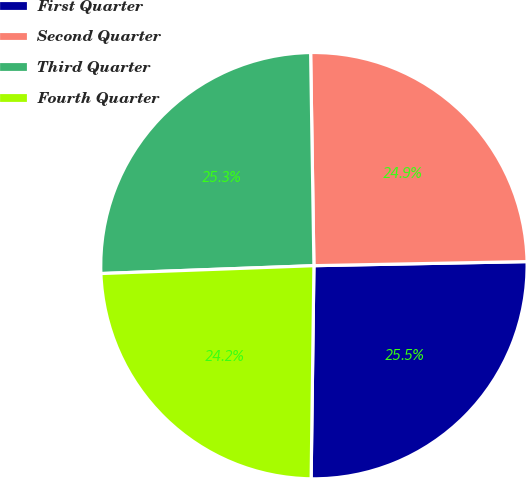<chart> <loc_0><loc_0><loc_500><loc_500><pie_chart><fcel>First Quarter<fcel>Second Quarter<fcel>Third Quarter<fcel>Fourth Quarter<nl><fcel>25.51%<fcel>24.94%<fcel>25.34%<fcel>24.2%<nl></chart> 